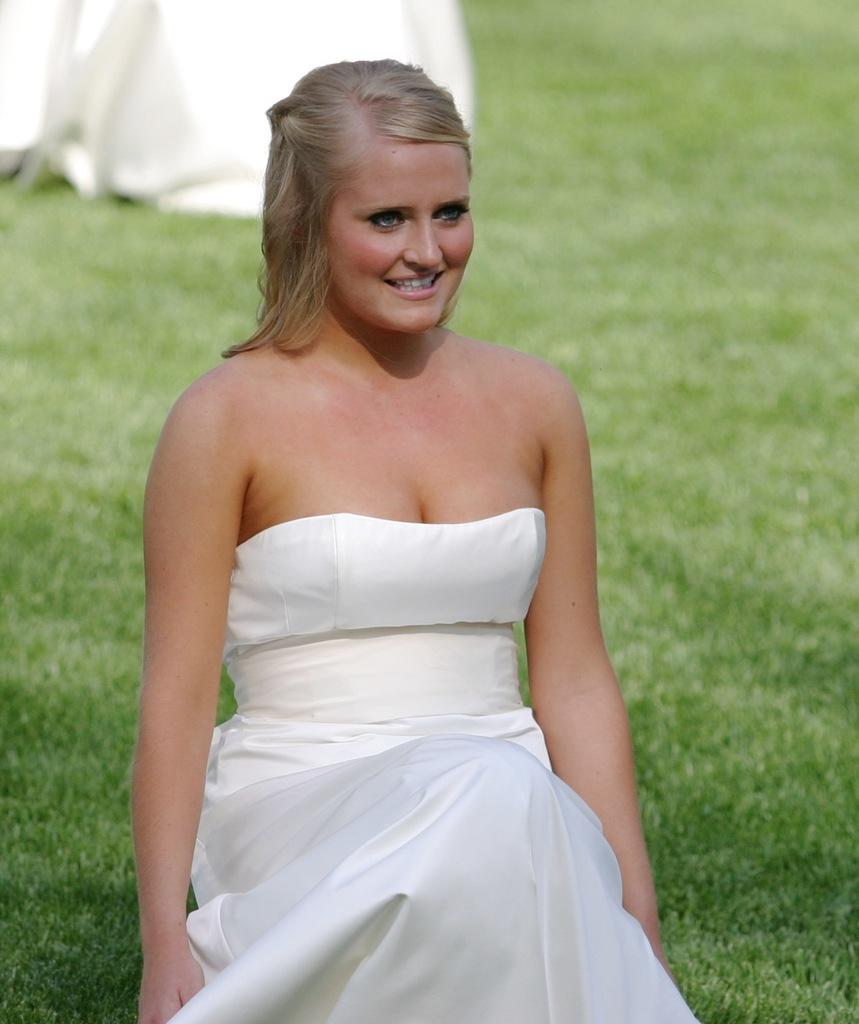Who is present in the image? There is a woman in the image. What is the woman's facial expression? The woman is smiling. What type of environment is visible in the background of the image? There is grass visible in the background of the image. How many babies are present in the image? There are no babies present in the image; it features a woman smiling. What type of destruction can be seen in the image? There is no destruction present in the image; it features a woman smiling in a grassy environment. 